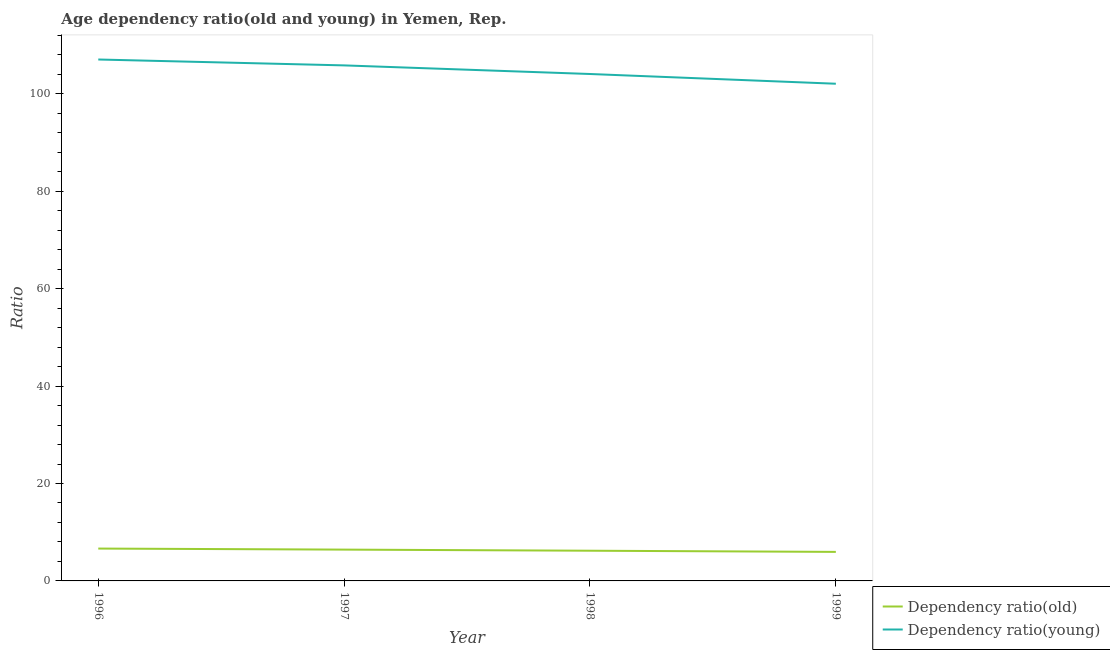Does the line corresponding to age dependency ratio(young) intersect with the line corresponding to age dependency ratio(old)?
Your response must be concise. No. Is the number of lines equal to the number of legend labels?
Keep it short and to the point. Yes. What is the age dependency ratio(young) in 1997?
Your answer should be very brief. 105.85. Across all years, what is the maximum age dependency ratio(young)?
Offer a terse response. 107.06. Across all years, what is the minimum age dependency ratio(young)?
Offer a terse response. 102.09. In which year was the age dependency ratio(young) maximum?
Provide a succinct answer. 1996. What is the total age dependency ratio(young) in the graph?
Your response must be concise. 419.09. What is the difference between the age dependency ratio(young) in 1996 and that in 1997?
Make the answer very short. 1.21. What is the difference between the age dependency ratio(old) in 1999 and the age dependency ratio(young) in 1998?
Keep it short and to the point. -98.12. What is the average age dependency ratio(old) per year?
Your answer should be compact. 6.31. In the year 1996, what is the difference between the age dependency ratio(young) and age dependency ratio(old)?
Offer a terse response. 100.42. In how many years, is the age dependency ratio(young) greater than 48?
Your answer should be compact. 4. What is the ratio of the age dependency ratio(young) in 1997 to that in 1999?
Ensure brevity in your answer.  1.04. Is the age dependency ratio(old) in 1997 less than that in 1998?
Keep it short and to the point. No. Is the difference between the age dependency ratio(old) in 1996 and 1999 greater than the difference between the age dependency ratio(young) in 1996 and 1999?
Ensure brevity in your answer.  No. What is the difference between the highest and the second highest age dependency ratio(old)?
Your answer should be compact. 0.21. What is the difference between the highest and the lowest age dependency ratio(old)?
Ensure brevity in your answer.  0.68. Does the age dependency ratio(young) monotonically increase over the years?
Provide a succinct answer. No. Is the age dependency ratio(young) strictly greater than the age dependency ratio(old) over the years?
Offer a terse response. Yes. Is the age dependency ratio(young) strictly less than the age dependency ratio(old) over the years?
Keep it short and to the point. No. Are the values on the major ticks of Y-axis written in scientific E-notation?
Provide a short and direct response. No. Does the graph contain any zero values?
Make the answer very short. No. How are the legend labels stacked?
Provide a short and direct response. Vertical. What is the title of the graph?
Keep it short and to the point. Age dependency ratio(old and young) in Yemen, Rep. Does "Quality of trade" appear as one of the legend labels in the graph?
Offer a very short reply. No. What is the label or title of the Y-axis?
Make the answer very short. Ratio. What is the Ratio in Dependency ratio(old) in 1996?
Keep it short and to the point. 6.64. What is the Ratio in Dependency ratio(young) in 1996?
Your response must be concise. 107.06. What is the Ratio in Dependency ratio(old) in 1997?
Your answer should be very brief. 6.43. What is the Ratio of Dependency ratio(young) in 1997?
Your response must be concise. 105.85. What is the Ratio of Dependency ratio(old) in 1998?
Ensure brevity in your answer.  6.2. What is the Ratio in Dependency ratio(young) in 1998?
Your response must be concise. 104.08. What is the Ratio of Dependency ratio(old) in 1999?
Offer a terse response. 5.96. What is the Ratio of Dependency ratio(young) in 1999?
Keep it short and to the point. 102.09. Across all years, what is the maximum Ratio in Dependency ratio(old)?
Provide a succinct answer. 6.64. Across all years, what is the maximum Ratio of Dependency ratio(young)?
Keep it short and to the point. 107.06. Across all years, what is the minimum Ratio in Dependency ratio(old)?
Offer a terse response. 5.96. Across all years, what is the minimum Ratio in Dependency ratio(young)?
Keep it short and to the point. 102.09. What is the total Ratio in Dependency ratio(old) in the graph?
Your answer should be very brief. 25.24. What is the total Ratio in Dependency ratio(young) in the graph?
Offer a terse response. 419.09. What is the difference between the Ratio of Dependency ratio(old) in 1996 and that in 1997?
Provide a short and direct response. 0.21. What is the difference between the Ratio in Dependency ratio(young) in 1996 and that in 1997?
Your answer should be compact. 1.21. What is the difference between the Ratio in Dependency ratio(old) in 1996 and that in 1998?
Ensure brevity in your answer.  0.44. What is the difference between the Ratio in Dependency ratio(young) in 1996 and that in 1998?
Provide a short and direct response. 2.98. What is the difference between the Ratio in Dependency ratio(old) in 1996 and that in 1999?
Your response must be concise. 0.68. What is the difference between the Ratio of Dependency ratio(young) in 1996 and that in 1999?
Make the answer very short. 4.98. What is the difference between the Ratio in Dependency ratio(old) in 1997 and that in 1998?
Your answer should be compact. 0.23. What is the difference between the Ratio in Dependency ratio(young) in 1997 and that in 1998?
Offer a terse response. 1.77. What is the difference between the Ratio of Dependency ratio(old) in 1997 and that in 1999?
Ensure brevity in your answer.  0.47. What is the difference between the Ratio in Dependency ratio(young) in 1997 and that in 1999?
Provide a short and direct response. 3.77. What is the difference between the Ratio in Dependency ratio(old) in 1998 and that in 1999?
Offer a terse response. 0.24. What is the difference between the Ratio in Dependency ratio(young) in 1998 and that in 1999?
Your answer should be very brief. 2. What is the difference between the Ratio of Dependency ratio(old) in 1996 and the Ratio of Dependency ratio(young) in 1997?
Your response must be concise. -99.21. What is the difference between the Ratio of Dependency ratio(old) in 1996 and the Ratio of Dependency ratio(young) in 1998?
Give a very brief answer. -97.44. What is the difference between the Ratio of Dependency ratio(old) in 1996 and the Ratio of Dependency ratio(young) in 1999?
Ensure brevity in your answer.  -95.44. What is the difference between the Ratio in Dependency ratio(old) in 1997 and the Ratio in Dependency ratio(young) in 1998?
Offer a terse response. -97.66. What is the difference between the Ratio in Dependency ratio(old) in 1997 and the Ratio in Dependency ratio(young) in 1999?
Ensure brevity in your answer.  -95.66. What is the difference between the Ratio of Dependency ratio(old) in 1998 and the Ratio of Dependency ratio(young) in 1999?
Your response must be concise. -95.88. What is the average Ratio in Dependency ratio(old) per year?
Provide a short and direct response. 6.31. What is the average Ratio of Dependency ratio(young) per year?
Offer a very short reply. 104.77. In the year 1996, what is the difference between the Ratio in Dependency ratio(old) and Ratio in Dependency ratio(young)?
Make the answer very short. -100.42. In the year 1997, what is the difference between the Ratio in Dependency ratio(old) and Ratio in Dependency ratio(young)?
Make the answer very short. -99.43. In the year 1998, what is the difference between the Ratio in Dependency ratio(old) and Ratio in Dependency ratio(young)?
Your answer should be very brief. -97.88. In the year 1999, what is the difference between the Ratio in Dependency ratio(old) and Ratio in Dependency ratio(young)?
Offer a terse response. -96.13. What is the ratio of the Ratio in Dependency ratio(old) in 1996 to that in 1997?
Your answer should be compact. 1.03. What is the ratio of the Ratio of Dependency ratio(young) in 1996 to that in 1997?
Ensure brevity in your answer.  1.01. What is the ratio of the Ratio in Dependency ratio(old) in 1996 to that in 1998?
Provide a succinct answer. 1.07. What is the ratio of the Ratio in Dependency ratio(young) in 1996 to that in 1998?
Offer a very short reply. 1.03. What is the ratio of the Ratio of Dependency ratio(old) in 1996 to that in 1999?
Your answer should be compact. 1.11. What is the ratio of the Ratio in Dependency ratio(young) in 1996 to that in 1999?
Offer a very short reply. 1.05. What is the ratio of the Ratio of Dependency ratio(old) in 1997 to that in 1998?
Offer a terse response. 1.04. What is the ratio of the Ratio in Dependency ratio(old) in 1997 to that in 1999?
Keep it short and to the point. 1.08. What is the ratio of the Ratio of Dependency ratio(young) in 1997 to that in 1999?
Make the answer very short. 1.04. What is the ratio of the Ratio in Dependency ratio(old) in 1998 to that in 1999?
Give a very brief answer. 1.04. What is the ratio of the Ratio in Dependency ratio(young) in 1998 to that in 1999?
Your response must be concise. 1.02. What is the difference between the highest and the second highest Ratio in Dependency ratio(old)?
Offer a terse response. 0.21. What is the difference between the highest and the second highest Ratio of Dependency ratio(young)?
Make the answer very short. 1.21. What is the difference between the highest and the lowest Ratio of Dependency ratio(old)?
Offer a very short reply. 0.68. What is the difference between the highest and the lowest Ratio of Dependency ratio(young)?
Your response must be concise. 4.98. 